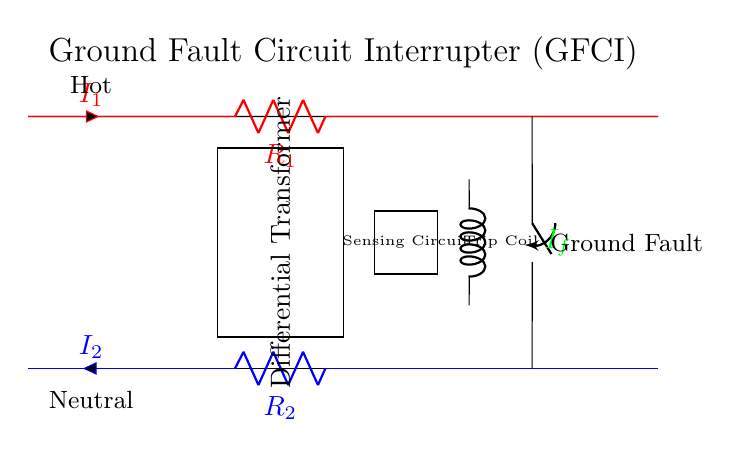What is the main purpose of the circuit? The main purpose of the Ground Fault Circuit Interrupter (GFCI) is to protect against electric shocks in wet environments by sensing imbalances in electrical current.
Answer: Protect against electric shocks What type of circuit component is used to detect ground faults? The differential transformer is used to detect the ground fault by comparing the current in the hot wire against the neutral wire, identifying any imbalance.
Answer: Differential transformer What do the colors red and blue represent in the wires? The red wire represents the hot wire carrying the current, while the blue wire represents the neutral wire returning the current back to the source.
Answer: Hot and neutral What activates the trip coil? The trip coil is activated when the sensing circuit identifies a ground fault, indicating that the current flowing in the hot wire is different from the current in the neutral wire.
Answer: Ground fault detection How many resistors are present in this circuit? There are two resistors in the circuit, labeled as R1 and R2, which are situated in the hot and neutral paths respectively.
Answer: Two What type of switch is included in this circuit, and what does it control? A switch is included to control the electricity flow through the circuit, allowing it to be turned on or off, and it is usually in the closed state for operation.
Answer: Switch 